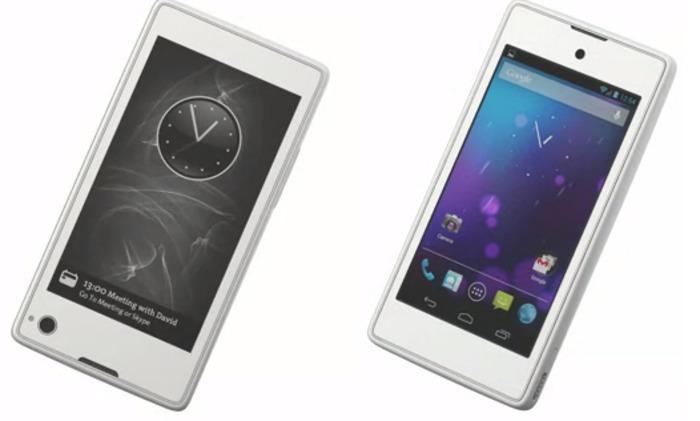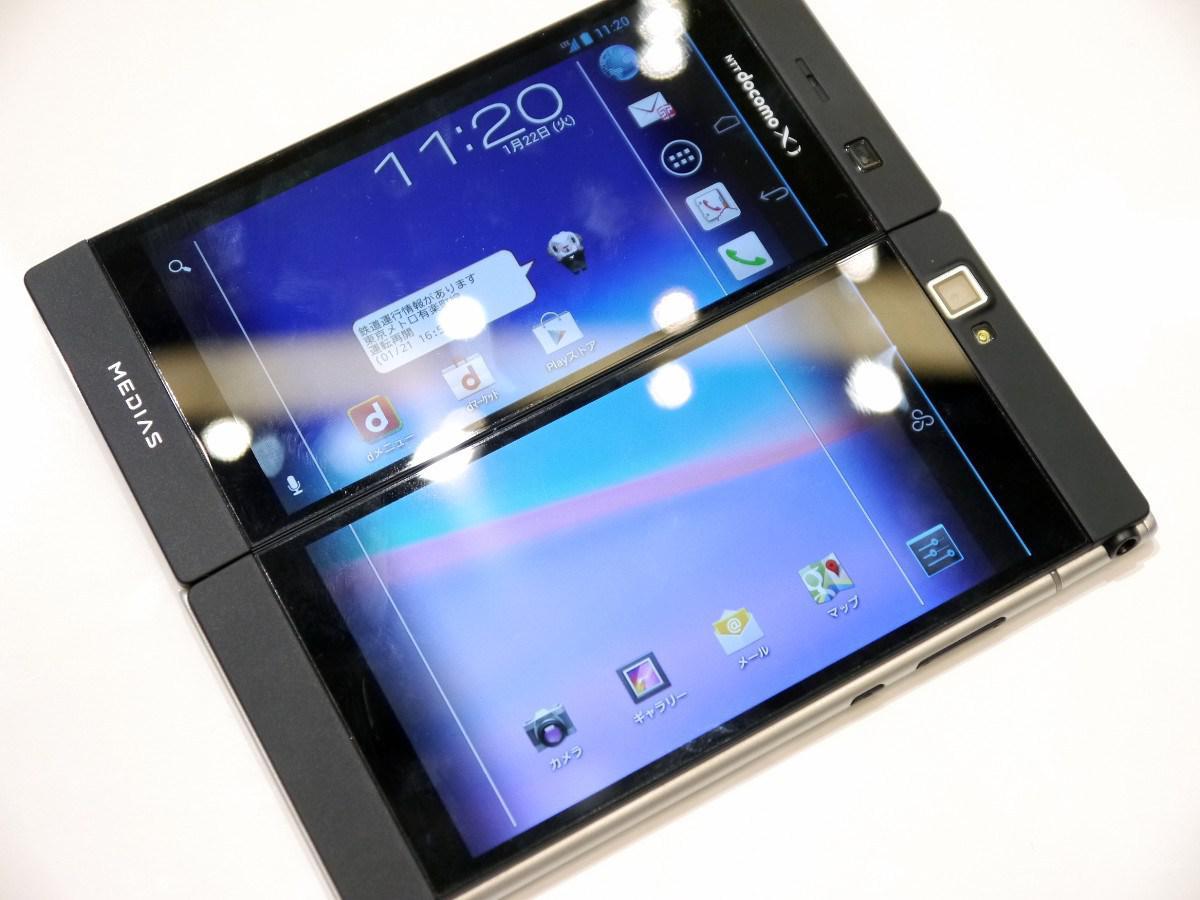The first image is the image on the left, the second image is the image on the right. Assess this claim about the two images: "The back of a phone is visible.". Correct or not? Answer yes or no. No. The first image is the image on the left, the second image is the image on the right. For the images displayed, is the sentence "One of the phones has physical keys for typing." factually correct? Answer yes or no. No. 